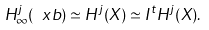<formula> <loc_0><loc_0><loc_500><loc_500>H _ { \infty } ^ { j } ( \ x b ) \simeq H ^ { j } ( X ) \simeq I ^ { t } H ^ { j } ( X ) .</formula> 